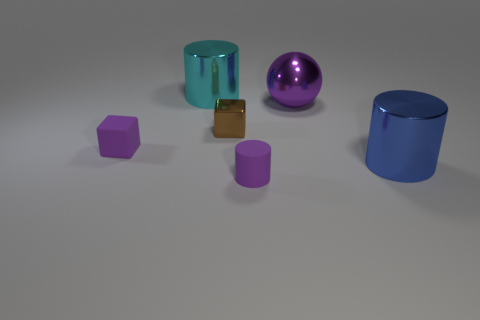Add 4 small matte blocks. How many objects exist? 10 Subtract all blocks. How many objects are left? 4 Subtract 1 purple cylinders. How many objects are left? 5 Subtract all yellow cubes. Subtract all large blue things. How many objects are left? 5 Add 3 big purple balls. How many big purple balls are left? 4 Add 5 small blue shiny cylinders. How many small blue shiny cylinders exist? 5 